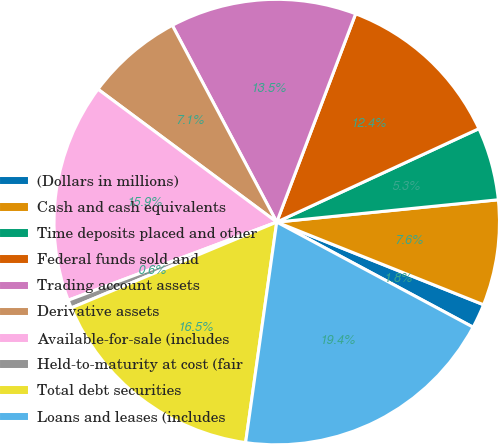Convert chart. <chart><loc_0><loc_0><loc_500><loc_500><pie_chart><fcel>(Dollars in millions)<fcel>Cash and cash equivalents<fcel>Time deposits placed and other<fcel>Federal funds sold and<fcel>Trading account assets<fcel>Derivative assets<fcel>Available-for-sale (includes<fcel>Held-to-maturity at cost (fair<fcel>Total debt securities<fcel>Loans and leases (includes<nl><fcel>1.77%<fcel>7.65%<fcel>5.29%<fcel>12.35%<fcel>13.53%<fcel>7.06%<fcel>15.88%<fcel>0.59%<fcel>16.47%<fcel>19.41%<nl></chart> 